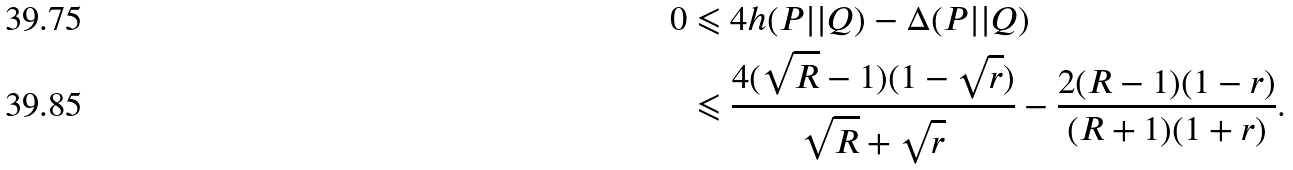<formula> <loc_0><loc_0><loc_500><loc_500>0 & \leqslant 4 h ( P | | Q ) - \Delta ( P | | Q ) \\ & \leqslant \frac { 4 ( \sqrt { R } - 1 ) ( 1 - \sqrt { r } ) } { \sqrt { R } + \sqrt { r } } - \frac { 2 ( R - 1 ) ( 1 - r ) } { ( R + 1 ) ( 1 + r ) } .</formula> 